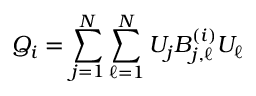Convert formula to latex. <formula><loc_0><loc_0><loc_500><loc_500>Q _ { i } = \sum _ { j = 1 } ^ { N } \sum _ { \ell = 1 } ^ { N } U _ { j } B _ { j , \ell } ^ { ( i ) } U _ { \ell }</formula> 